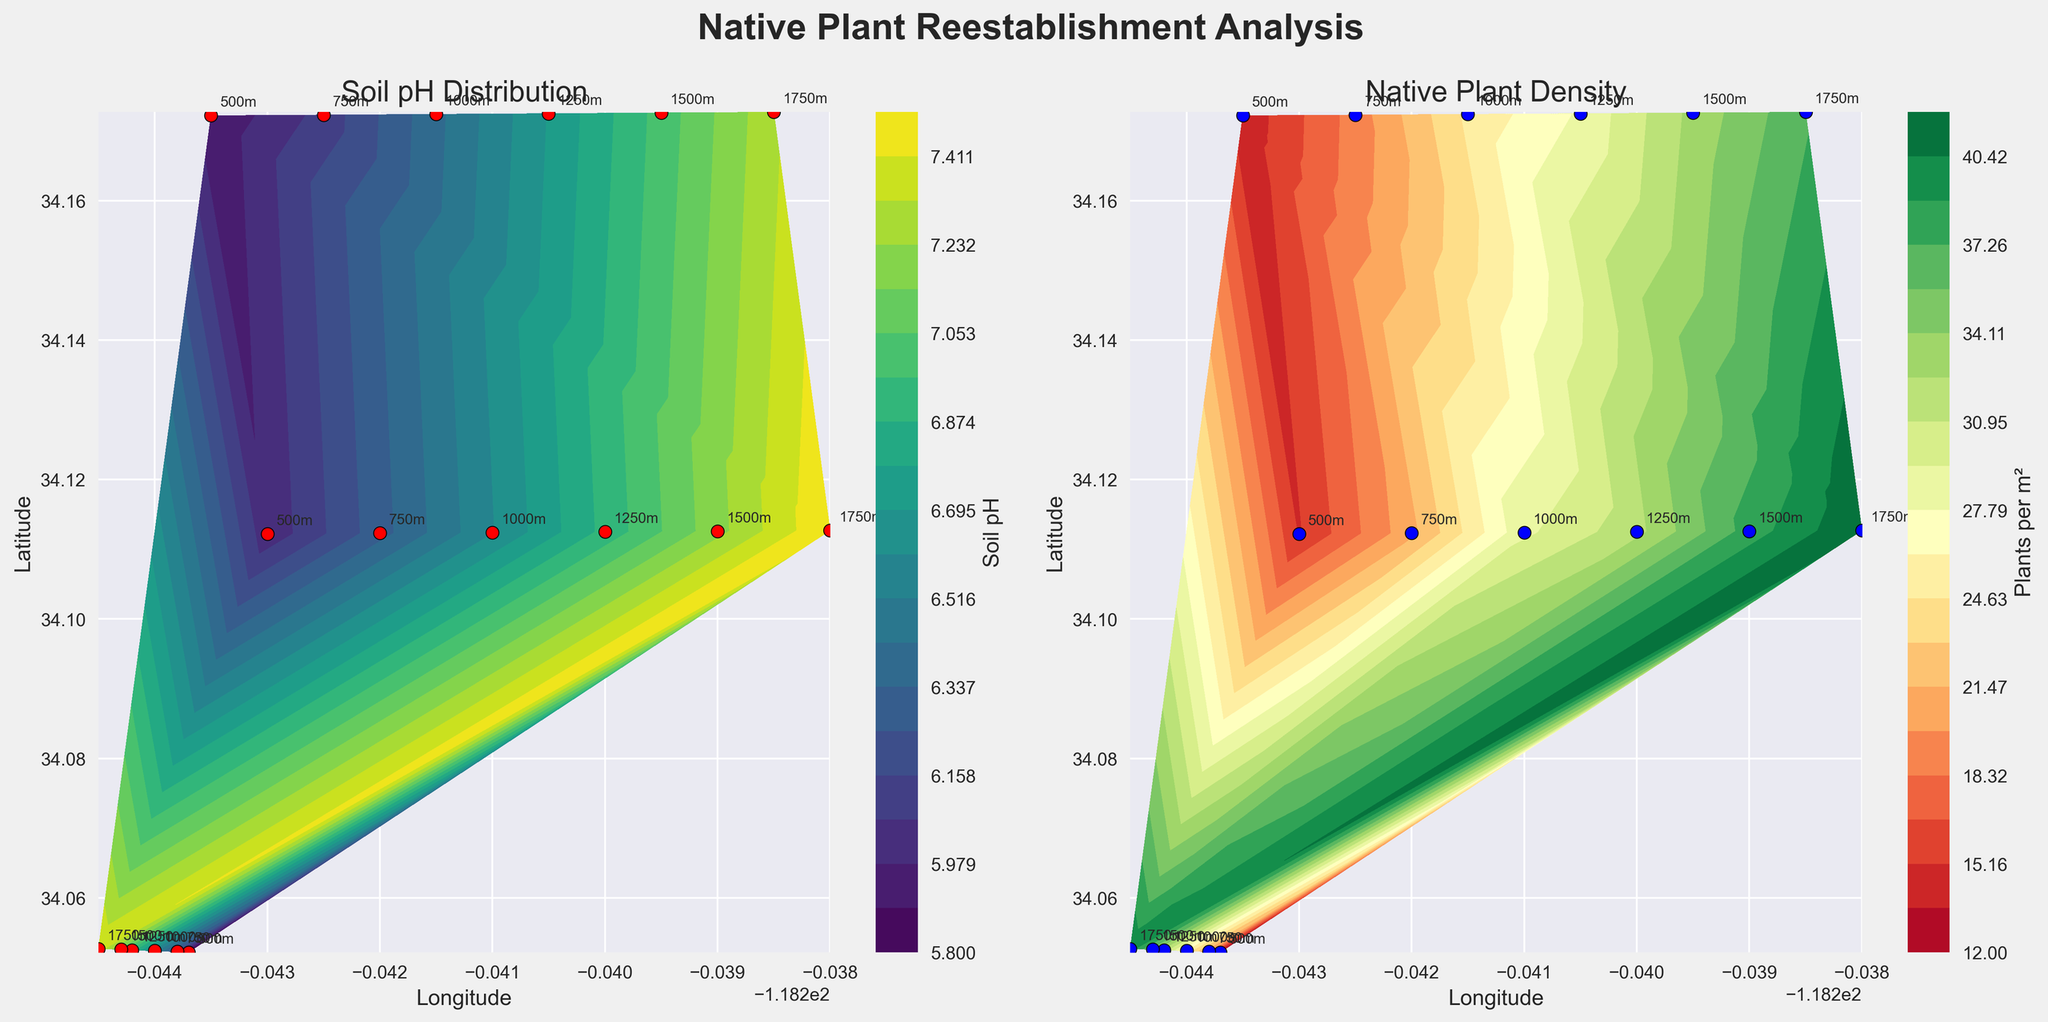What's the title of the first subplot? The first subplot's title is positioned above it. It reads "Soil pH Distribution".
Answer: "Soil pH Distribution" How many data points are plotted on the Native Plant Density plot? Each data point is represented by a blue dot on the Native Plant Density plot. By counting the blue dots, we see there are 18 data points.
Answer: 18 At what elevation is the soil pH approximately 6.8? On the Soil pH Distribution plot, elevation annotations are provided next to the data points. The data point with a pH of approximately 6.8 corresponds to the label 1250m.
Answer: 1250 meters Which subplot uses the color map 'viridis'? The color map 'viridis' is used in the plot with the title "Soil pH Distribution", which is the first subplot.
Answer: The first subplot How does Native Plant Density change as elevation increases? Observing the Native Plant Density plot shows that density tends to increase as the annotations for elevation also increase. At higher elevations (like 1750m), we see a higher density compared to lower elevations (like 500m).
Answer: Increases What is the average Soil pH value at the highest recorded elevations? The highest recorded elevations are 1750m. The Soil pH values at these elevations are 7.4, 7.5, and 7.3. The average can be calculated as (7.4 + 7.5 + 7.3) / 3 = 7.4
Answer: 7.4 Which elevation point has the highest Native Plant Density? From the annotations in the Native Plant Density plot, the highest density value (42 plants per m²) is at the elevation of 1750m.
Answer: 1750 meters Between 500m and 1000m elevations, how much does the Soil pH increase? The Soil pH at 500m is around 5.8-6.0, while at 1000m, it's around 6.4-6.6. This shows an increase of approximately 0.6-0.8 units.
Answer: 0.6-0.8 units Which color represents the highest native plant density in the second subplot? The second subplot uses the 'RdYlGn' color map, which transitions from red to yellow to green. Green represents higher densities.
Answer: Green Are the elevation annotations the same for both subplots? By comparing the annotations on both subplots, it is evident that the elevations are consistently labelled (e.g., 500m, 750m) across both plots.
Answer: Yes 